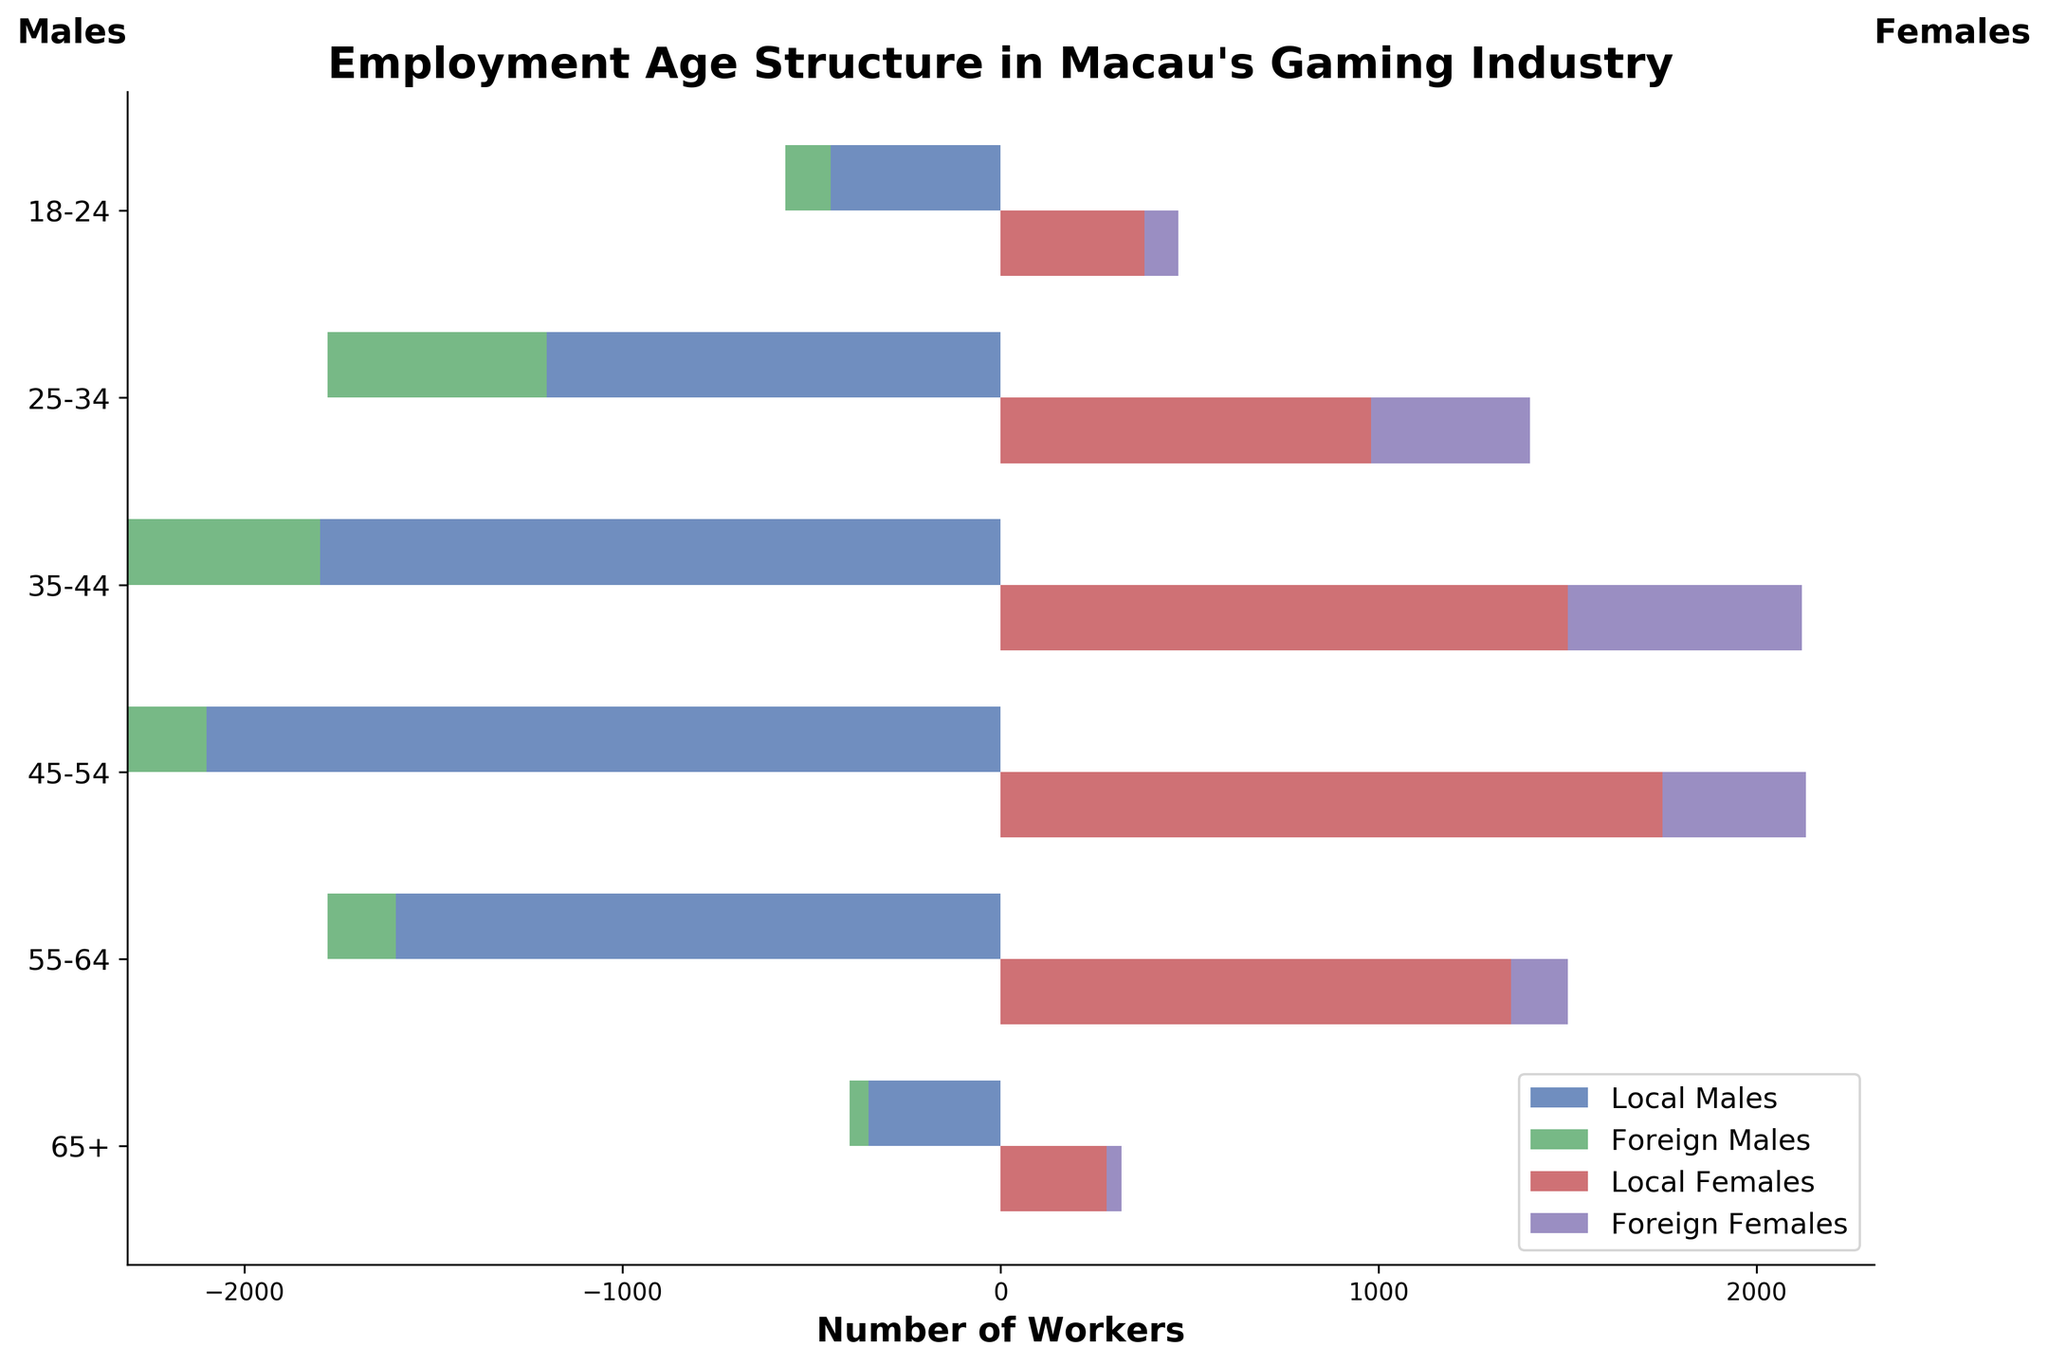Which age group has the highest number of local male workers? By observing the local male workers bar's negative value position on the horizontal axis and the length of the bar, the age group with the largest length will have the highest number of local male workers. The 45-54 age group has the longest bar.
Answer: 45-54 How many workers are there in total in the 25-34 age group? Sum the numbers for all categories in the 25-34 age group: 1200 (Local Males) + 980 (Local Females) + 580 (Foreign Males) + 420 (Foreign Females) = 3180.
Answer: 3180 Who is more predominant in the 65+ age group, local or foreign workers? Compare the bars for local workers (both males and females) with bars for foreign workers (both males and females) in the 65+ age group. Local workers have both longer bars.
Answer: Local workers What is the total number of foreign male workers across all age groups? Add the numbers of foreign male workers across all age groups: 120 + 580 + 780 + 450 + 180 + 50 = 2160.
Answer: 2160 In which age group do local female workers surpass foreign female workers by the highest margin? Calculate the difference between local female and foreign female workers in each age group: 
18-24: 380-90 = 290 
25-34: 980-420 = 560 
35-44: 1500-620 = 880 
45-54: 1750-380 = 1370 
55-64: 1350-150 = 1200 
65+: 280-40 = 240. 
45-54 has the highest difference.
Answer: 45-54 Compare the number of local workers in the 35-44 age group with foreign workers in the same group. Which is larger, and by how much? Calculate the total local and foreign workers in the 35-44 group: Local workers: 1800 (Males) + 1500 (Females) = 3300. Foreign workers: 780 (Males) + 620 (Females) = 1400. The difference is 3300 - 1400 = 1900. Local workers are larger by 1900.
Answer: Local workers, 1900 What percentage of workers in the 55-64 age group are foreign females? Total workers in 55-64 age group: 1600 (Local Males) + 1350 (Local Females) + 180 (Foreign Males) + 150 (Foreign Females) = 3280. Foreign females: 150. Percentage: (150/3280) * 100 ≈ 4.57%.
Answer: 4.57% Which gender has more foreign workers in the 25-34 age group? Compare the foreign male and female workers in the 25-34 age group: 580 (Foreign Males) vs 420 (Foreign Females). Foreign males are more.
Answer: Males 